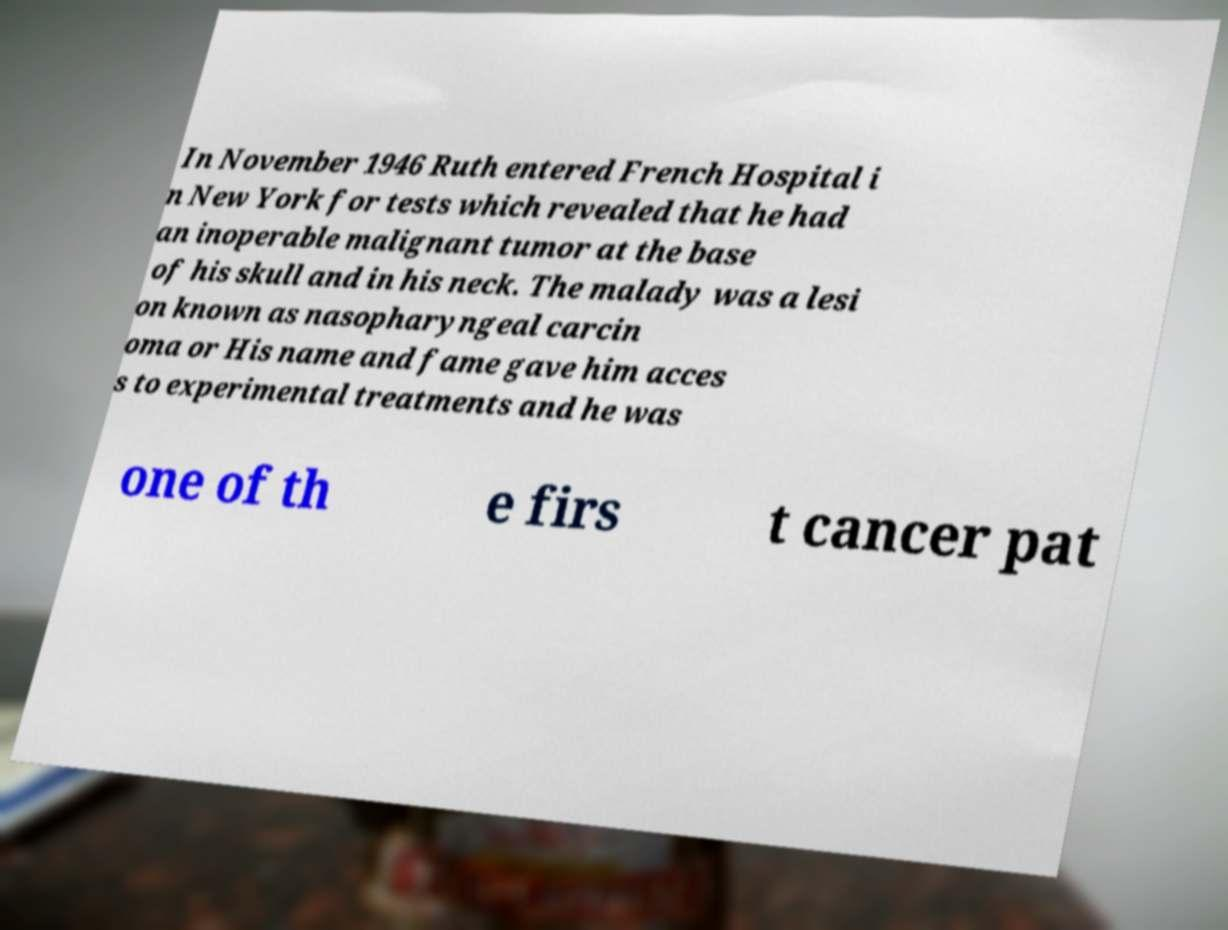Could you assist in decoding the text presented in this image and type it out clearly? In November 1946 Ruth entered French Hospital i n New York for tests which revealed that he had an inoperable malignant tumor at the base of his skull and in his neck. The malady was a lesi on known as nasopharyngeal carcin oma or His name and fame gave him acces s to experimental treatments and he was one of th e firs t cancer pat 